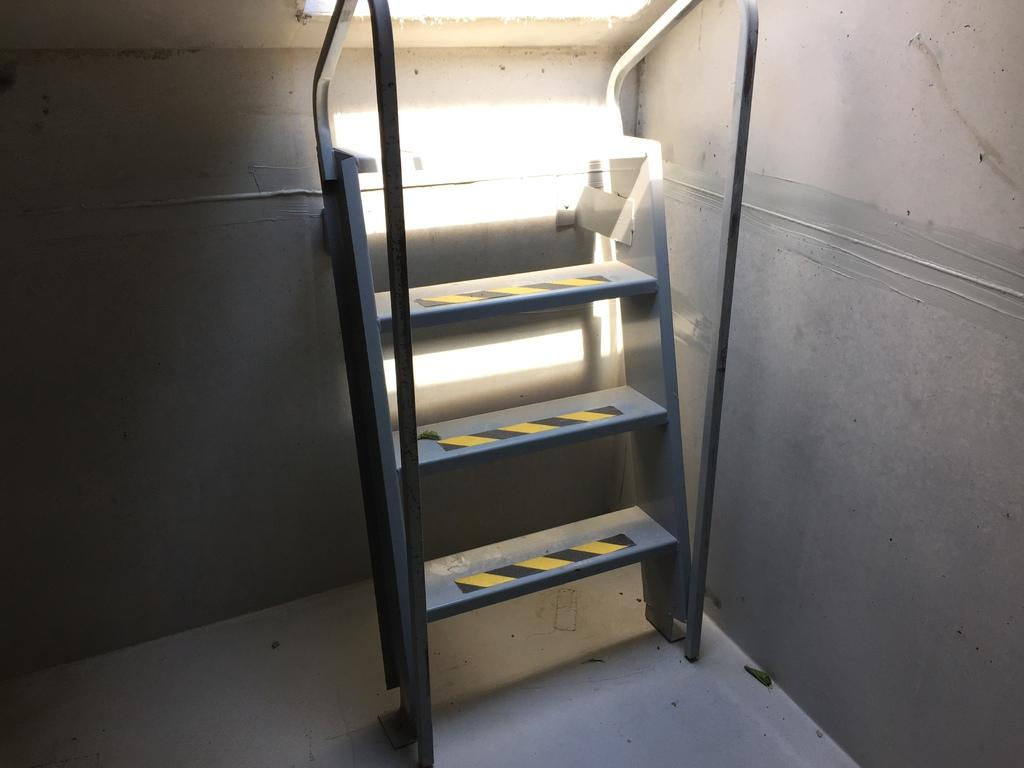What type of ladder is in the image? There is an iron ladder in the image. What color is the wall in the image? The wall in the image is cream-colored. How many trucks are carrying coal in the image? There are no trucks or coal present in the image. What type of jewel is hanging from the ladder in the image? There is no jewel hanging from the ladder in the image; it is an iron ladder without any additional decorations. 